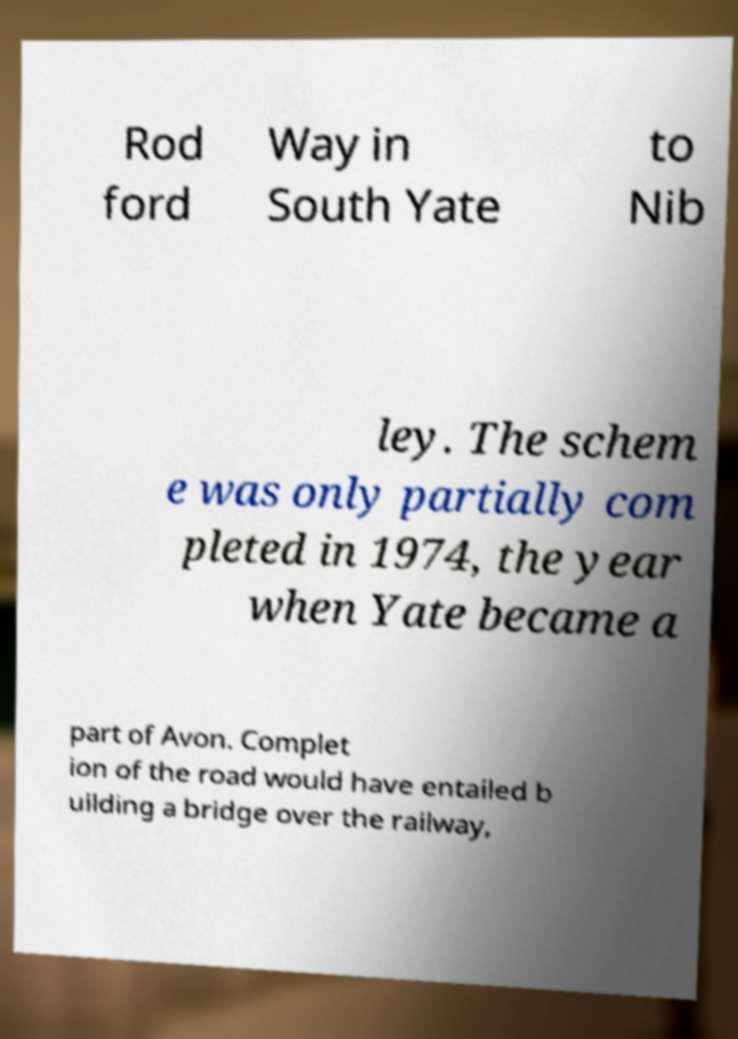Can you accurately transcribe the text from the provided image for me? Rod ford Way in South Yate to Nib ley. The schem e was only partially com pleted in 1974, the year when Yate became a part of Avon. Complet ion of the road would have entailed b uilding a bridge over the railway, 